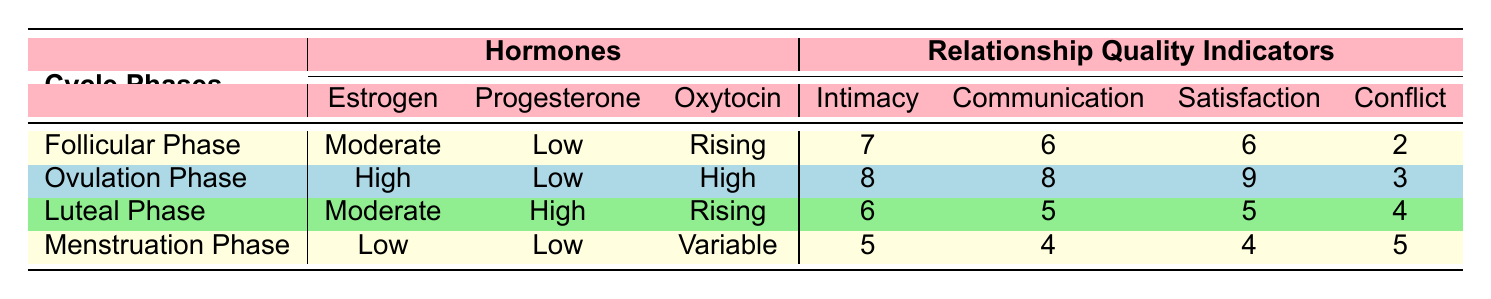What hormone levels are present during the Ovulation Phase? According to the table, during the Ovulation Phase, the levels of Estrogen are High, Progesterone is Low, and Oxytocin is High.
Answer: High Estrogen, Low Progesterone, High Oxytocin What is the Intimacy score during the Luteal Phase? The Intimacy score provided in the table for the Luteal Phase is 6.
Answer: 6 During which phase is the Satisfaction score the highest? By inspecting the table, the Satisfaction scores reveal that the highest score of 9 occurs during the Ovulation Phase.
Answer: Ovulation Phase What is the average Communication score across all phases? To find the average, add the scores: (6 + 8 + 5 + 4) = 23 and then divide by the number of phases (4), which gives 23/4 = 5.75.
Answer: 5.75 Is the Conflict score higher during Menstruation Phase compared to the Follicular Phase? The Conflict score during Menstruation is 5, while during Follicular Phase it is 2. Thus, Menstruation Phase has a higher Conflict score than Follicular Phase.
Answer: Yes What is the trend of Intimacy scores across the cycle phases? The Intimacy scores are as follows: 7 in Follicular Phase, 8 in Ovulation Phase, 6 in Luteal Phase, and 5 in Menstruation Phase. This shows an increase to Ovulation and then a decrease afterward.
Answer: Increase then decrease Which phase has the lowest levels of Estrogen? From the table, the Menstruation Phase shows the lowest level of Estrogen, which is Low.
Answer: Menstruation Phase What is the difference in Satisfaction scores between the Ovulation Phase and the Luteal Phase? The Satisfaction score during Ovulation is 9 and during Luteal Phase is 5. The difference is 9 - 5 = 4.
Answer: 4 Is Oxytocin rising during the Luteal Phase? According to the table, Oxytocin is described as Rising during the Luteal Phase. Hence, the statement is true.
Answer: Yes What is the relationship quality indicator combination with the highest scores during any phase? The Ovulation Phase has the highest scores: Intimacy (8), Communication (8), Satisfaction (9).
Answer: Ovulation Phase: Intimacy 8, Communication 8, Satisfaction 9 